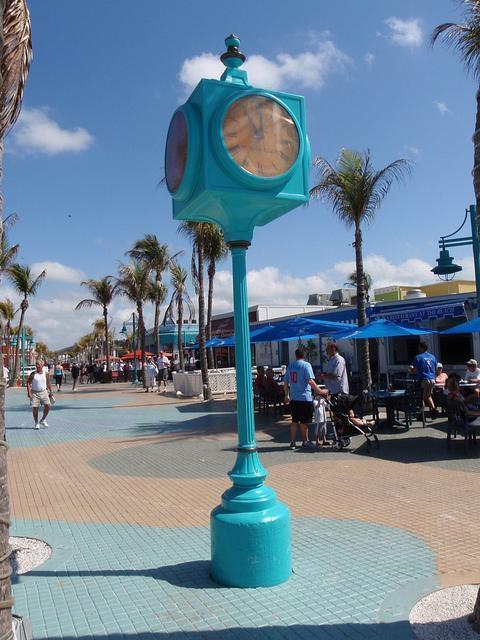How many people are there?
Give a very brief answer. 2. How many clocks can be seen?
Give a very brief answer. 2. 